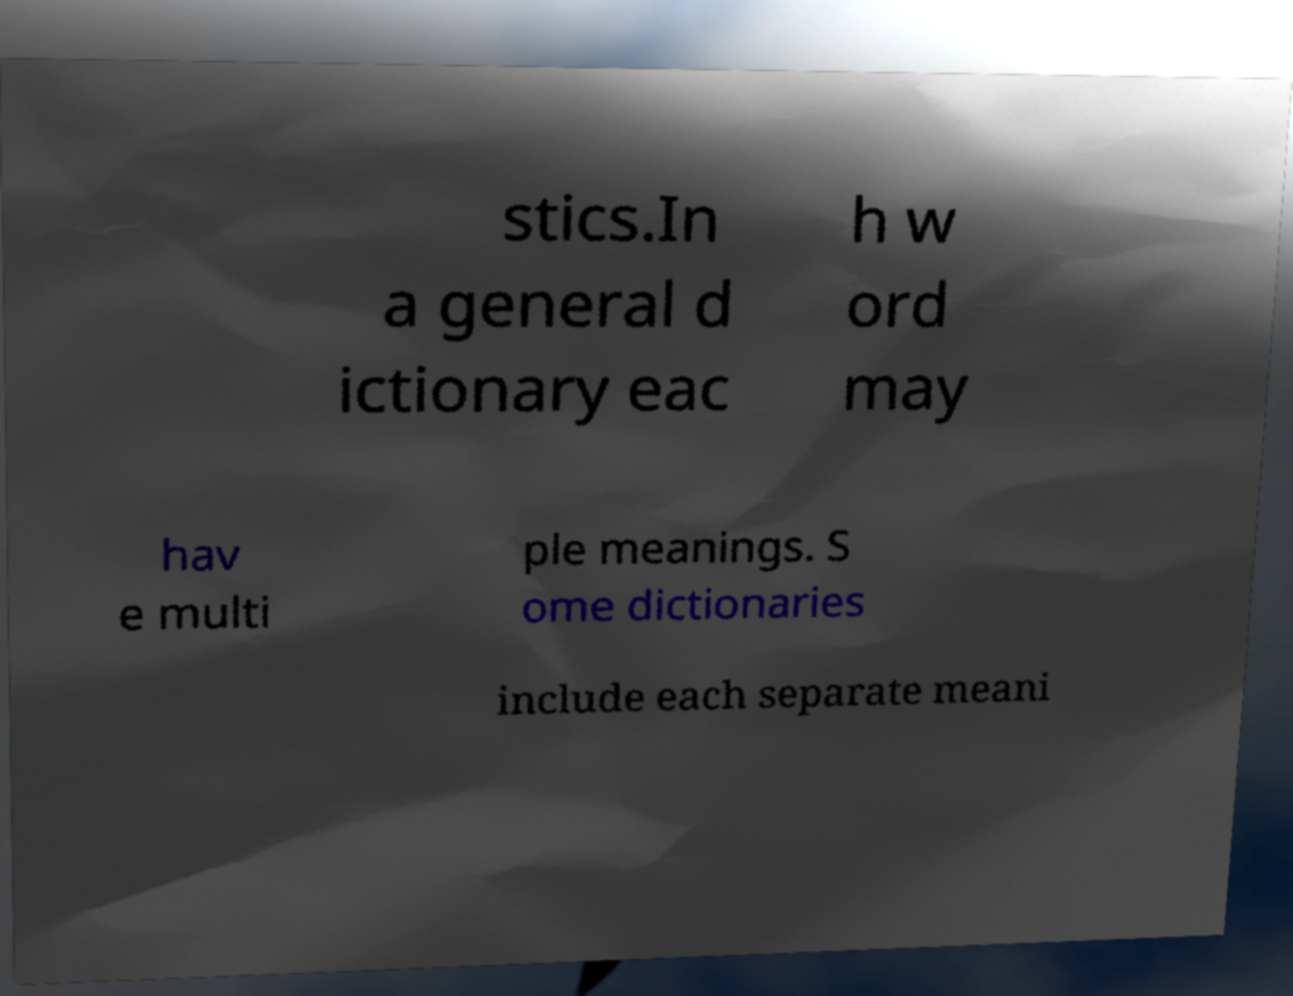There's text embedded in this image that I need extracted. Can you transcribe it verbatim? stics.In a general d ictionary eac h w ord may hav e multi ple meanings. S ome dictionaries include each separate meani 